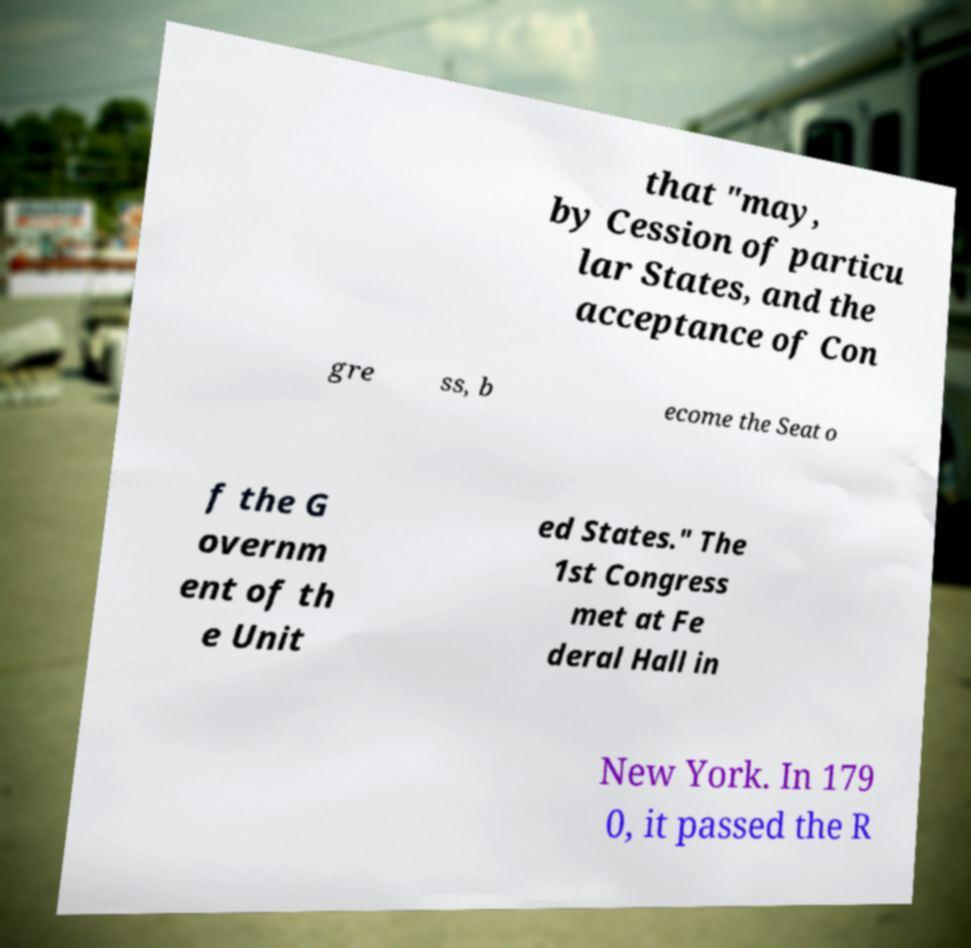For documentation purposes, I need the text within this image transcribed. Could you provide that? that "may, by Cession of particu lar States, and the acceptance of Con gre ss, b ecome the Seat o f the G overnm ent of th e Unit ed States." The 1st Congress met at Fe deral Hall in New York. In 179 0, it passed the R 